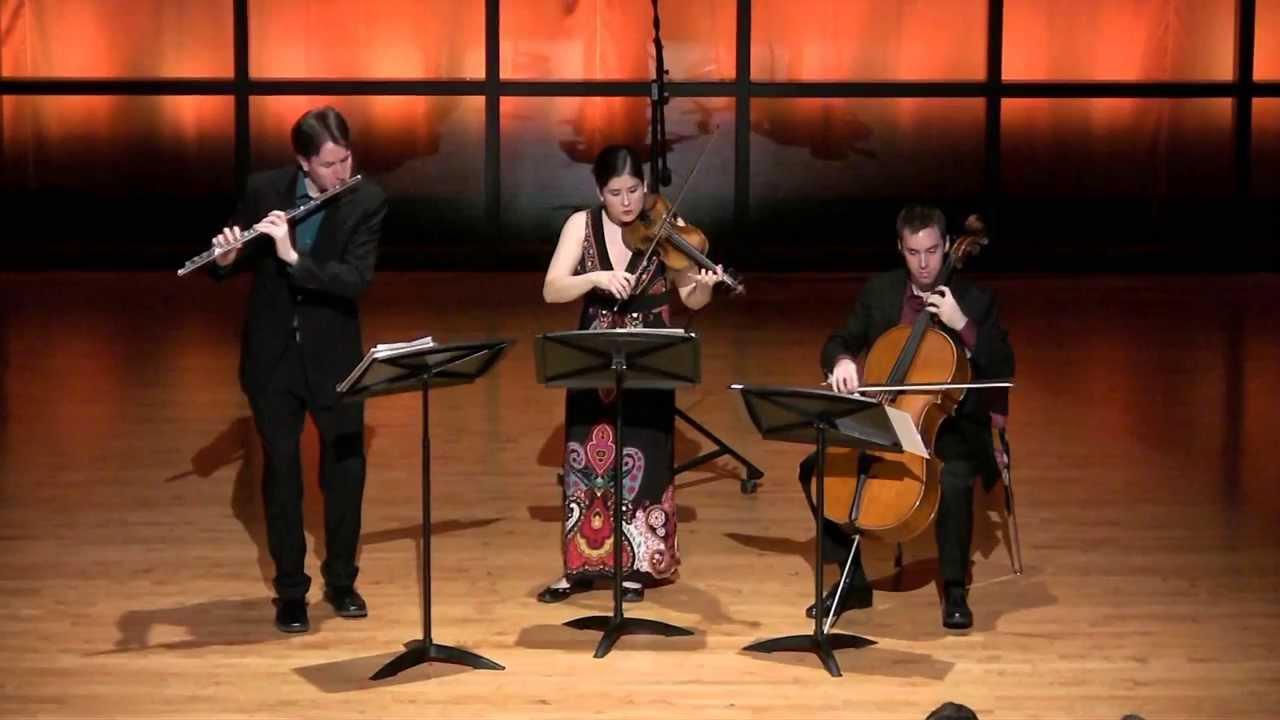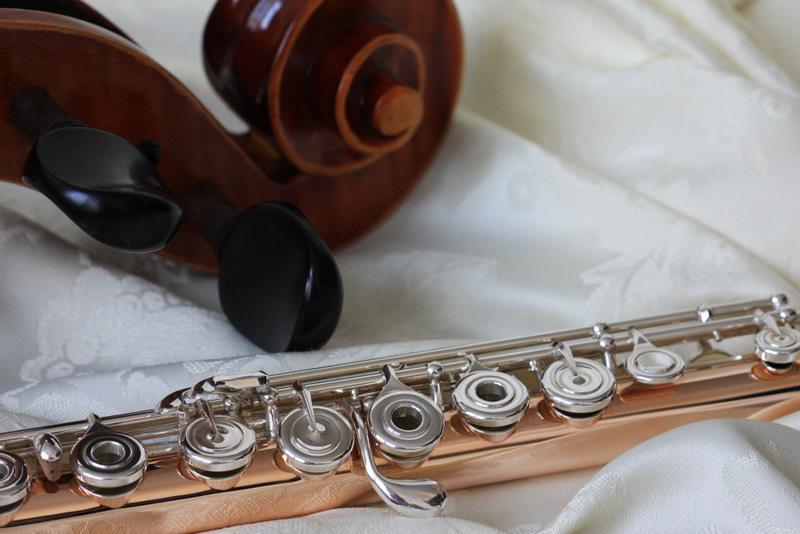The first image is the image on the left, the second image is the image on the right. Given the left and right images, does the statement "The left image shows a trio of musicians on a stage, with the person on the far left standing playing a wind instrument and the person on the far right sitting playing a string instrument." hold true? Answer yes or no. Yes. The first image is the image on the left, the second image is the image on the right. Considering the images on both sides, is "The left image contains three humans on a stage playing musical instruments." valid? Answer yes or no. Yes. 